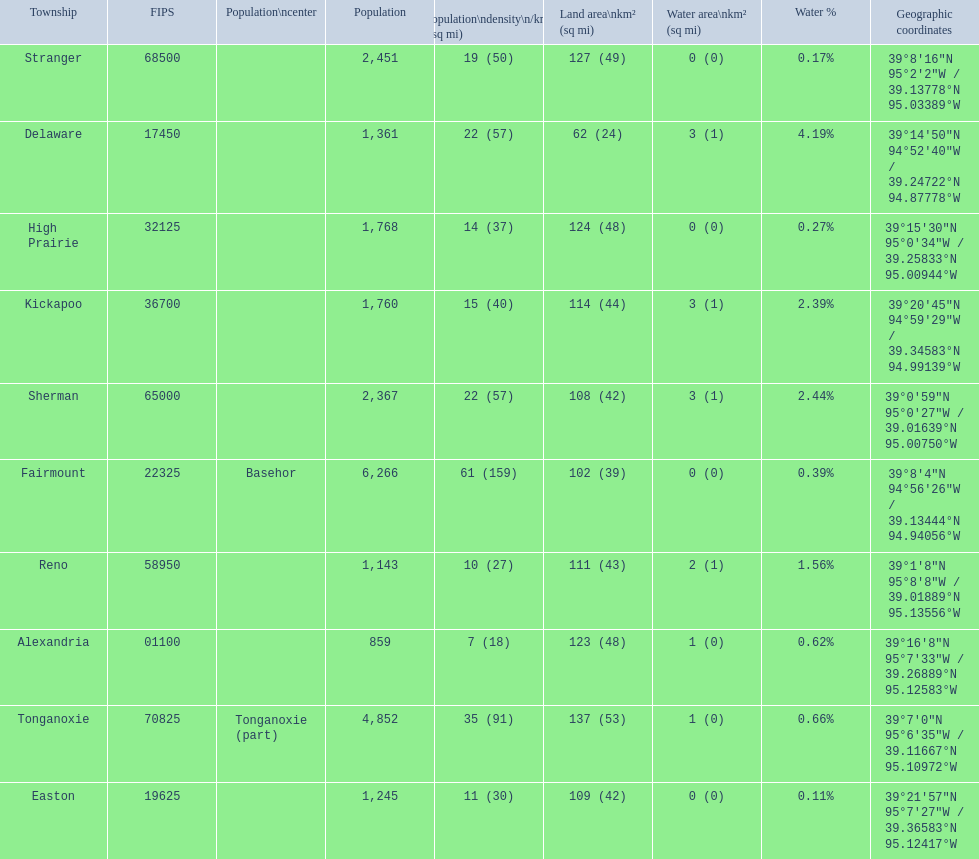How many townships are in leavenworth county? 10. 